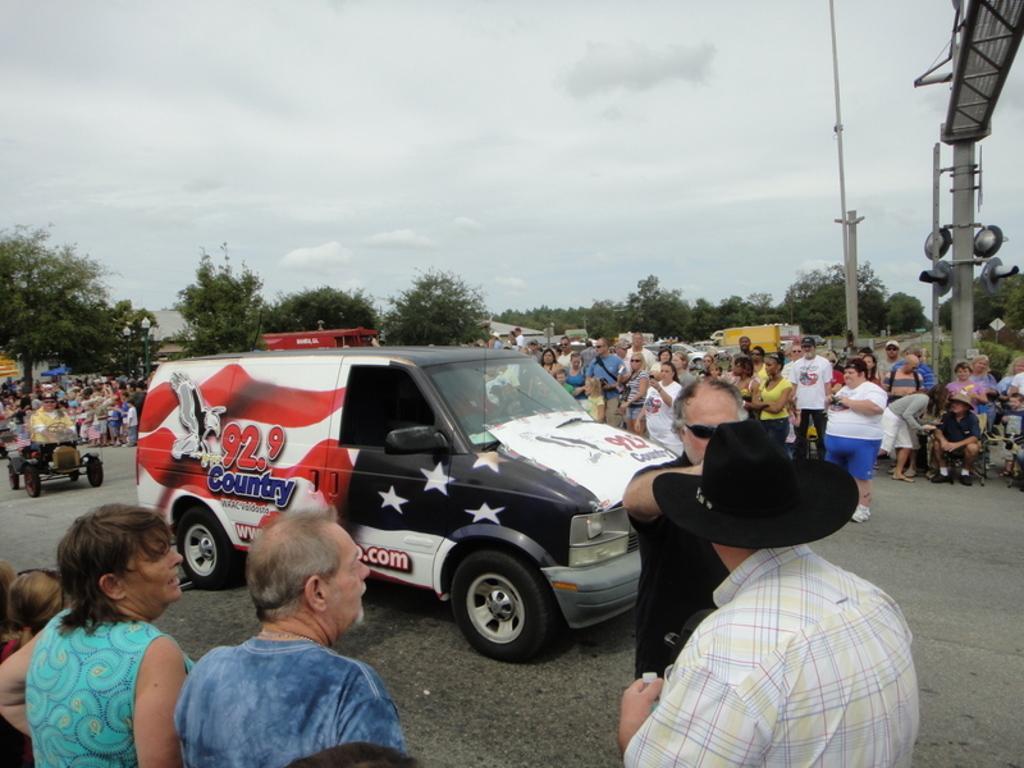How would you summarize this image in a sentence or two? In this image I can see group of people standing, in front I can see a vehicle in white, red and black color. Background I can see trees in green color and sky in white color. 